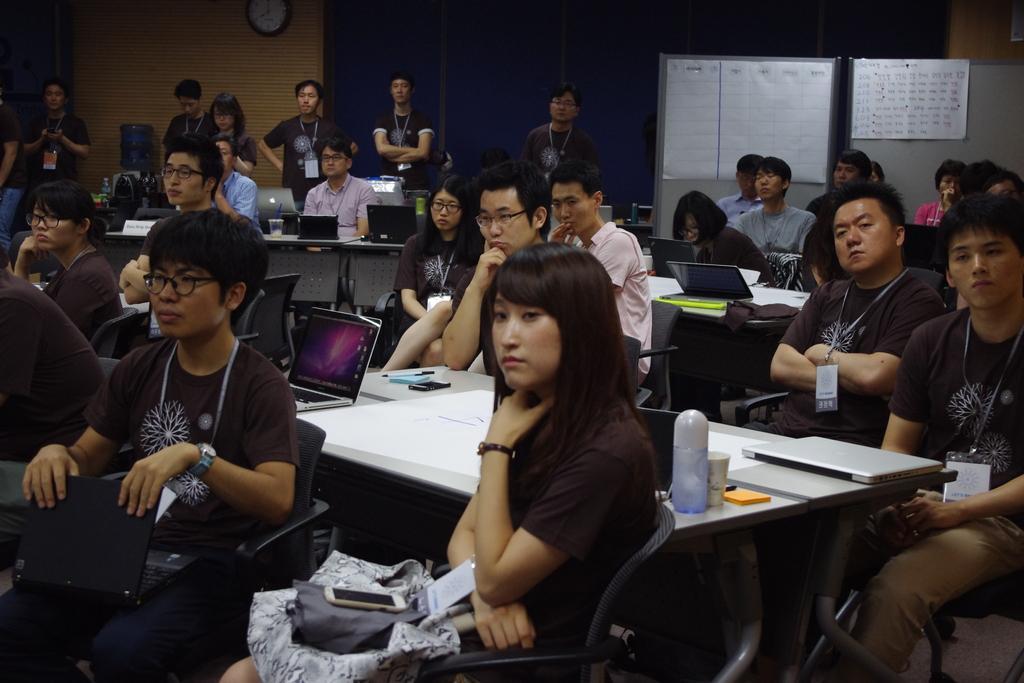Describe this image in one or two sentences. This is a picture taken in a room, there are a group of people sitting on a chair in front of the people there is a table on the table there is a bottle, cup, stick notes, and a laptop. Background of this people is a wall on the wall there is a clock and a paper. 